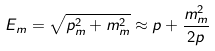<formula> <loc_0><loc_0><loc_500><loc_500>E _ { m } = \sqrt { p ^ { 2 } _ { m } + m _ { m } ^ { 2 } } \approx p + \frac { m _ { m } ^ { 2 } } { 2 p }</formula> 